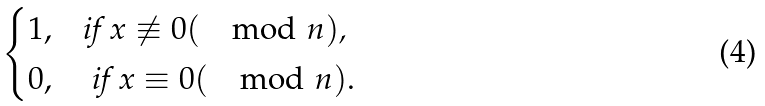Convert formula to latex. <formula><loc_0><loc_0><loc_500><loc_500>\begin{cases} 1 , & \text {if $ x \not \equiv 0 (\mod n)$, } \\ 0 , & \text { if $ x \equiv 0 (\mod n)$} . \end{cases}</formula> 